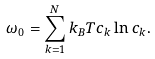<formula> <loc_0><loc_0><loc_500><loc_500>\omega _ { 0 } = \sum _ { k = 1 } ^ { N } k _ { B } T c _ { k } \ln c _ { k } .</formula> 